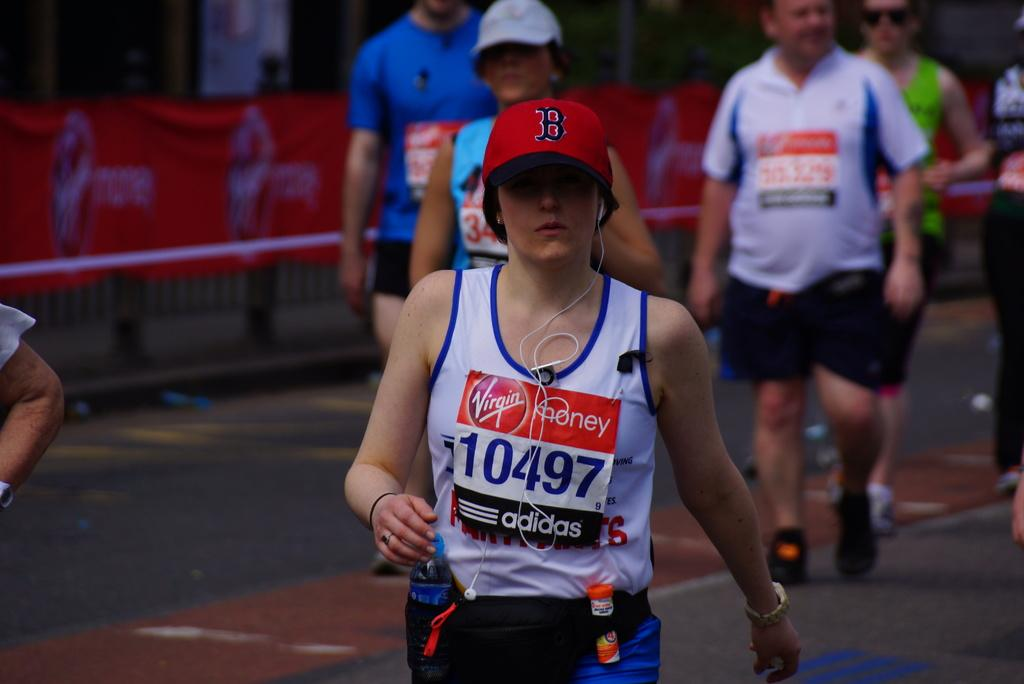<image>
Present a compact description of the photo's key features. people in a race wear bibs with Virgin Money and Adidas on them 